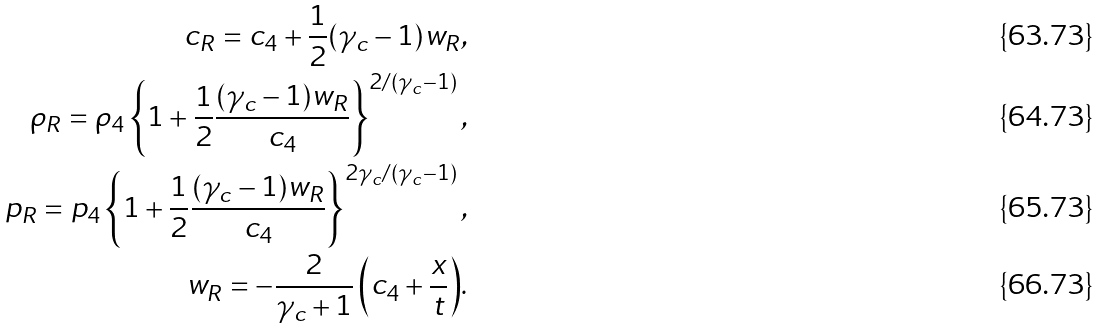Convert formula to latex. <formula><loc_0><loc_0><loc_500><loc_500>c _ { R } = c _ { 4 } + { \frac { 1 } { 2 } } ( \gamma _ { c } - 1 ) w _ { R } , \\ \rho _ { R } = \rho _ { 4 } \left \{ 1 + { \frac { 1 } { 2 } } \frac { ( \gamma _ { c } - 1 ) w _ { R } } { c _ { 4 } } \right \} ^ { 2 / ( \gamma _ { c } - 1 ) } , \\ p _ { R } = p _ { 4 } \left \{ 1 + { \frac { 1 } { 2 } } \frac { ( \gamma _ { c } - 1 ) w _ { R } } { c _ { 4 } } \right \} ^ { 2 \gamma _ { c } / ( \gamma _ { c } - 1 ) } , \\ w _ { R } = { - { \frac { 2 } { \gamma _ { c } + 1 } } \left ( c _ { 4 } + { \frac { x } { t } } \right ) } .</formula> 